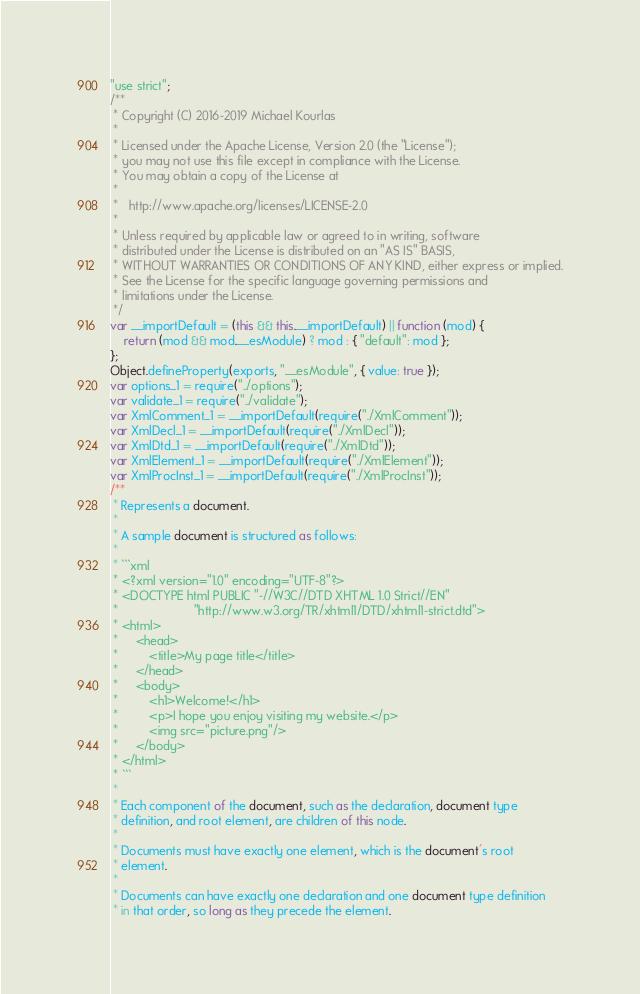Convert code to text. <code><loc_0><loc_0><loc_500><loc_500><_JavaScript_>"use strict";
/**
 * Copyright (C) 2016-2019 Michael Kourlas
 *
 * Licensed under the Apache License, Version 2.0 (the "License");
 * you may not use this file except in compliance with the License.
 * You may obtain a copy of the License at
 *
 *   http://www.apache.org/licenses/LICENSE-2.0
 *
 * Unless required by applicable law or agreed to in writing, software
 * distributed under the License is distributed on an "AS IS" BASIS,
 * WITHOUT WARRANTIES OR CONDITIONS OF ANY KIND, either express or implied.
 * See the License for the specific language governing permissions and
 * limitations under the License.
 */
var __importDefault = (this && this.__importDefault) || function (mod) {
    return (mod && mod.__esModule) ? mod : { "default": mod };
};
Object.defineProperty(exports, "__esModule", { value: true });
var options_1 = require("../options");
var validate_1 = require("../validate");
var XmlComment_1 = __importDefault(require("./XmlComment"));
var XmlDecl_1 = __importDefault(require("./XmlDecl"));
var XmlDtd_1 = __importDefault(require("./XmlDtd"));
var XmlElement_1 = __importDefault(require("./XmlElement"));
var XmlProcInst_1 = __importDefault(require("./XmlProcInst"));
/**
 * Represents a document.
 *
 * A sample document is structured as follows:
 *
 * ```xml
 * <?xml version="1.0" encoding="UTF-8"?>
 * <DOCTYPE html PUBLIC "-//W3C//DTD XHTML 1.0 Strict//EN"
 *                      "http://www.w3.org/TR/xhtml1/DTD/xhtml1-strict.dtd">
 * <html>
 *     <head>
 *         <title>My page title</title>
 *     </head>
 *     <body>
 *         <h1>Welcome!</h1>
 *         <p>I hope you enjoy visiting my website.</p>
 *         <img src="picture.png"/>
 *     </body>
 * </html>
 * ```
 *
 * Each component of the document, such as the declaration, document type
 * definition, and root element, are children of this node.
 *
 * Documents must have exactly one element, which is the document's root
 * element.
 *
 * Documents can have exactly one declaration and one document type definition
 * in that order, so long as they precede the element.</code> 